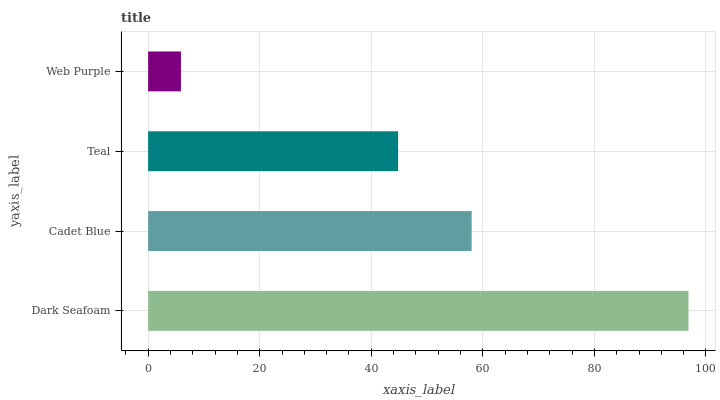Is Web Purple the minimum?
Answer yes or no. Yes. Is Dark Seafoam the maximum?
Answer yes or no. Yes. Is Cadet Blue the minimum?
Answer yes or no. No. Is Cadet Blue the maximum?
Answer yes or no. No. Is Dark Seafoam greater than Cadet Blue?
Answer yes or no. Yes. Is Cadet Blue less than Dark Seafoam?
Answer yes or no. Yes. Is Cadet Blue greater than Dark Seafoam?
Answer yes or no. No. Is Dark Seafoam less than Cadet Blue?
Answer yes or no. No. Is Cadet Blue the high median?
Answer yes or no. Yes. Is Teal the low median?
Answer yes or no. Yes. Is Teal the high median?
Answer yes or no. No. Is Web Purple the low median?
Answer yes or no. No. 